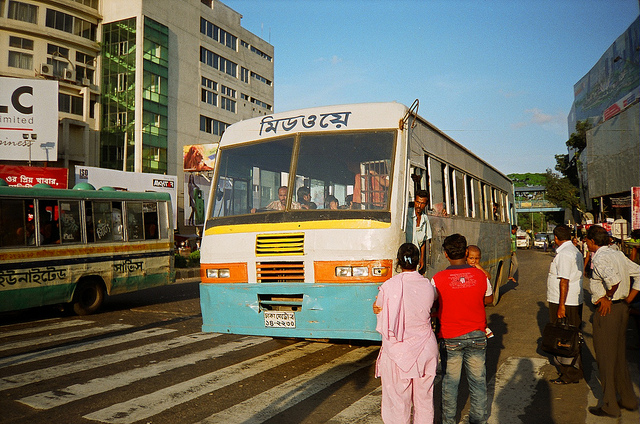Please transcribe the text in this image. ISO mited c 